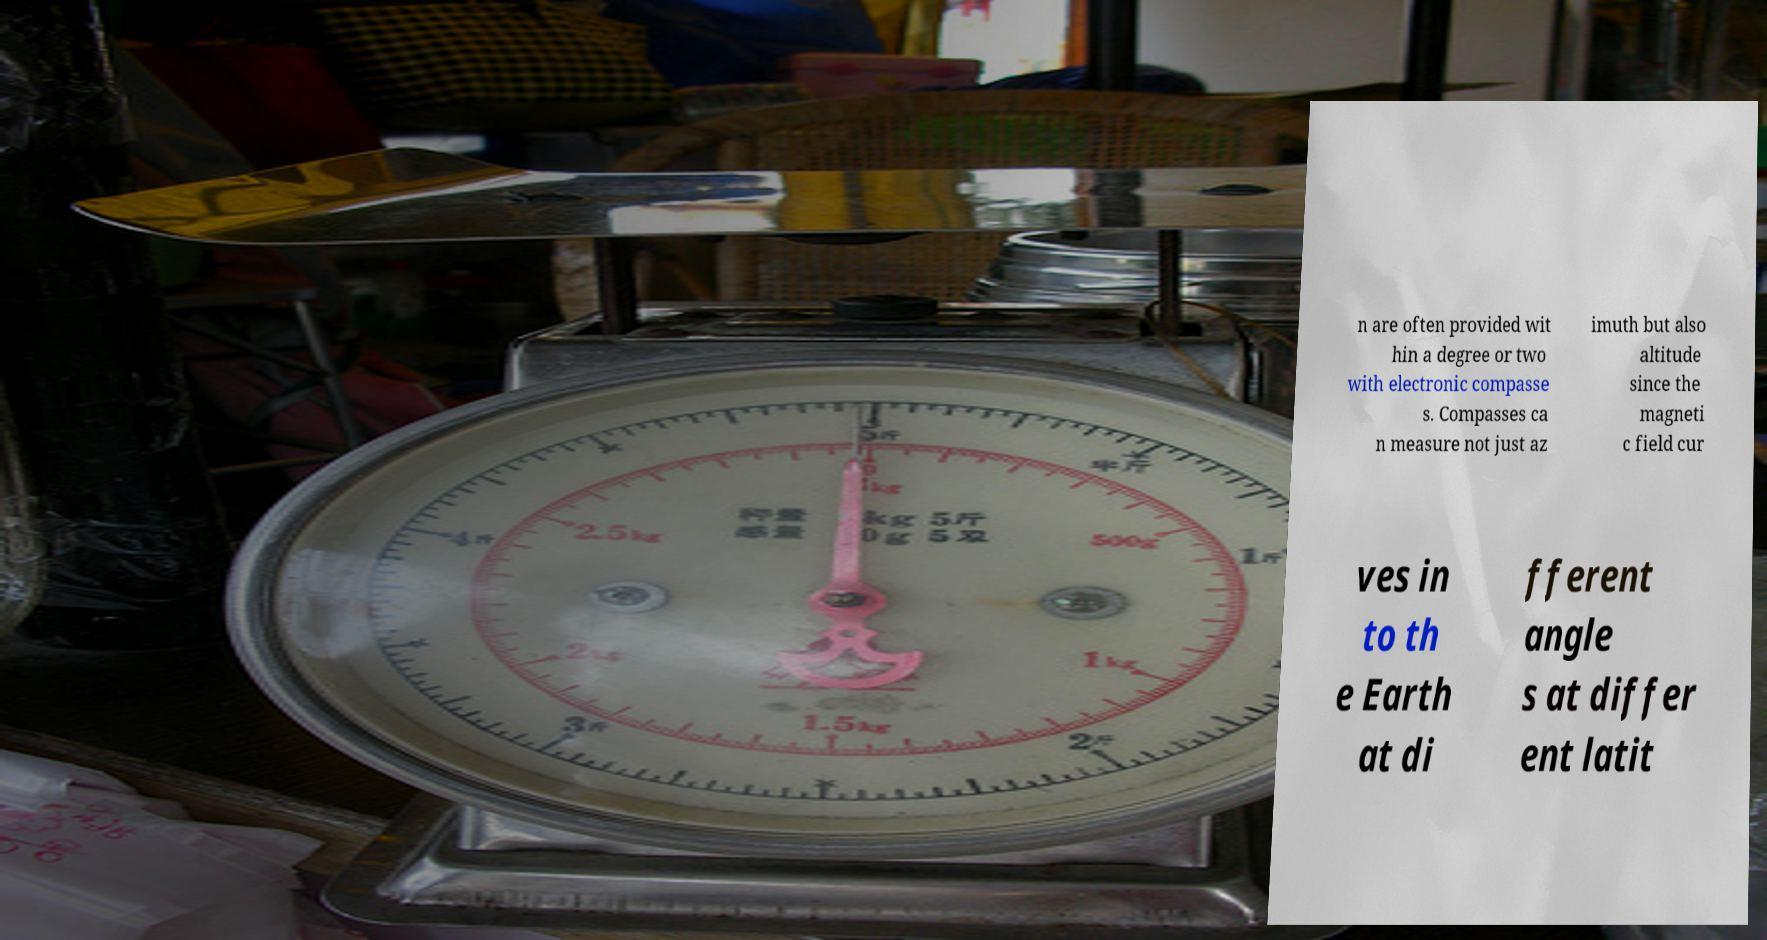Please read and relay the text visible in this image. What does it say? n are often provided wit hin a degree or two with electronic compasse s. Compasses ca n measure not just az imuth but also altitude since the magneti c field cur ves in to th e Earth at di fferent angle s at differ ent latit 